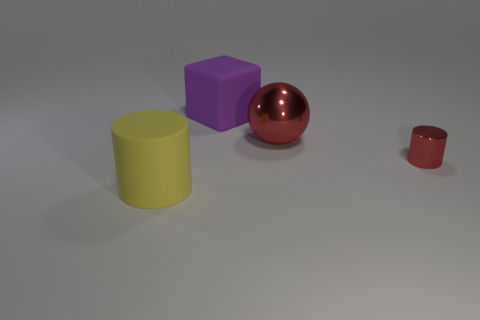Add 4 big rubber cylinders. How many objects exist? 8 Subtract all cubes. How many objects are left? 3 Subtract 0 purple cylinders. How many objects are left? 4 Subtract all gray shiny balls. Subtract all tiny red cylinders. How many objects are left? 3 Add 3 purple matte things. How many purple matte things are left? 4 Add 3 large purple things. How many large purple things exist? 4 